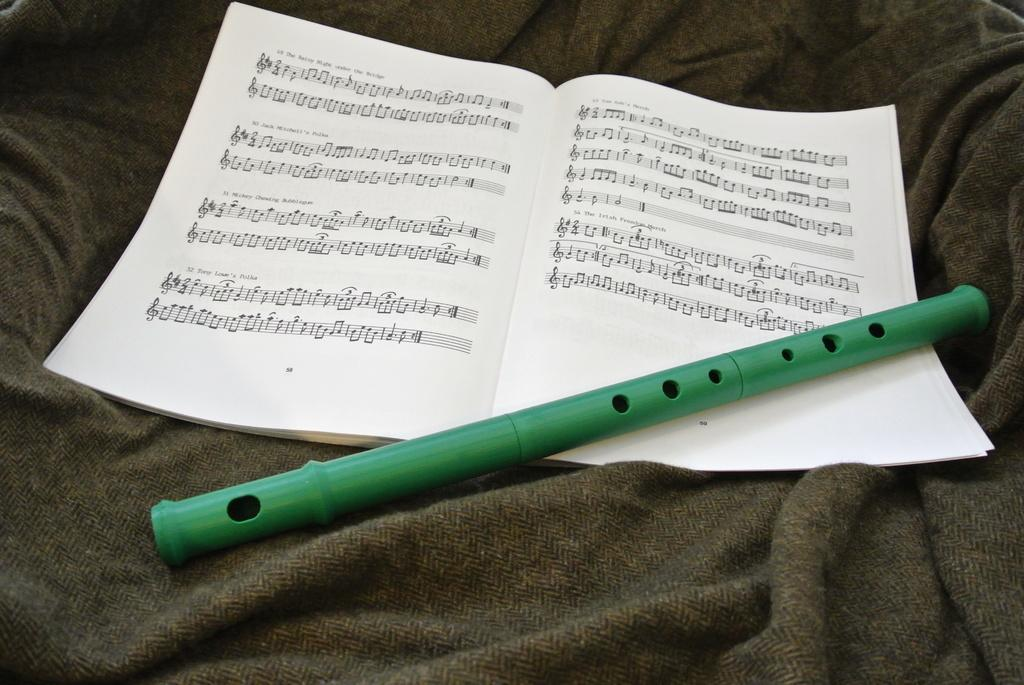What musical instrument is present in the image? There is a flute in the image. What is the color of the flute? The flute is green in color. What other object can be seen in the image? There is a book in the image. On what surface is the book placed? The book is on a cloth. How does the flute help the beginner in the image? There is no beginner present in the image, and the flute is not shown being used or interacted with in any way. 